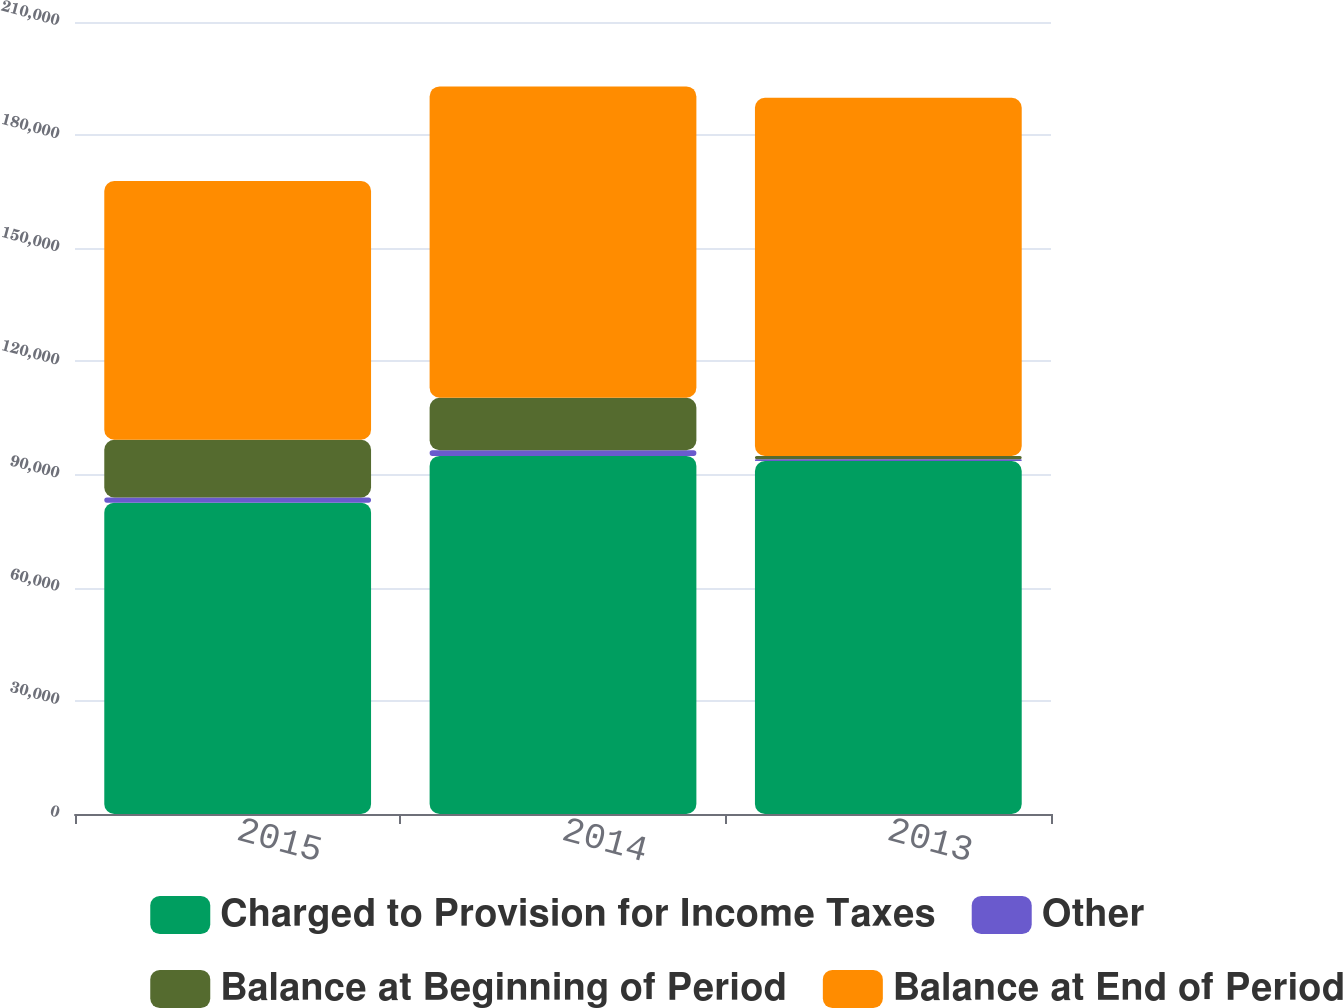Convert chart to OTSL. <chart><loc_0><loc_0><loc_500><loc_500><stacked_bar_chart><ecel><fcel>2015<fcel>2014<fcel>2013<nl><fcel>Charged to Provision for Income Taxes<fcel>82550<fcel>94952<fcel>93576<nl><fcel>Other<fcel>1363<fcel>1505<fcel>484<nl><fcel>Balance at Beginning of Period<fcel>15318<fcel>13907<fcel>892<nl><fcel>Balance at End of Period<fcel>68595<fcel>82550<fcel>94952<nl></chart> 